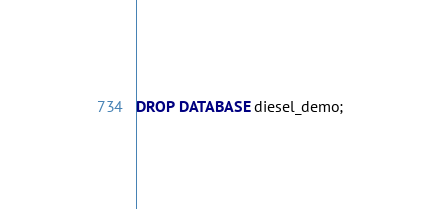<code> <loc_0><loc_0><loc_500><loc_500><_SQL_>DROP DATABASE diesel_demo;
</code> 